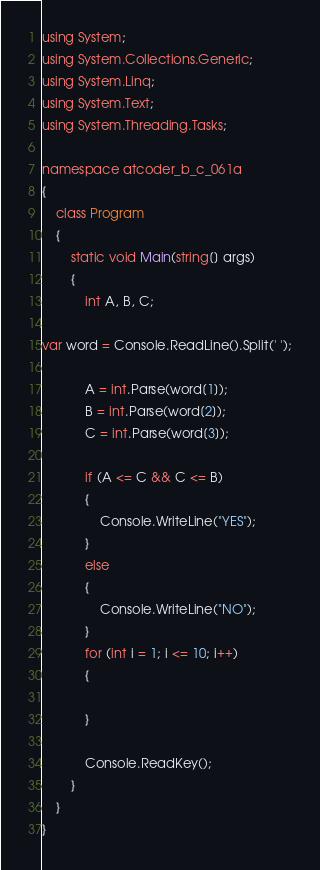Convert code to text. <code><loc_0><loc_0><loc_500><loc_500><_C#_>using System;
using System.Collections.Generic;
using System.Linq;
using System.Text;
using System.Threading.Tasks;

namespace atcoder_b_c_061a
{
    class Program
    {
        static void Main(string[] args)
        {
            int A, B, C;

var word = Console.ReadLine().Split(' ');

            A = int.Parse(word[1]);
            B = int.Parse(word[2]);
            C = int.Parse(word[3]);

            if (A <= C && C <= B)
            {
                Console.WriteLine("YES");
            }
            else
            {
                Console.WriteLine("NO");
            }
            for (int i = 1; i <= 10; i++)
            {

            }

            Console.ReadKey();
        }
    }
}
</code> 